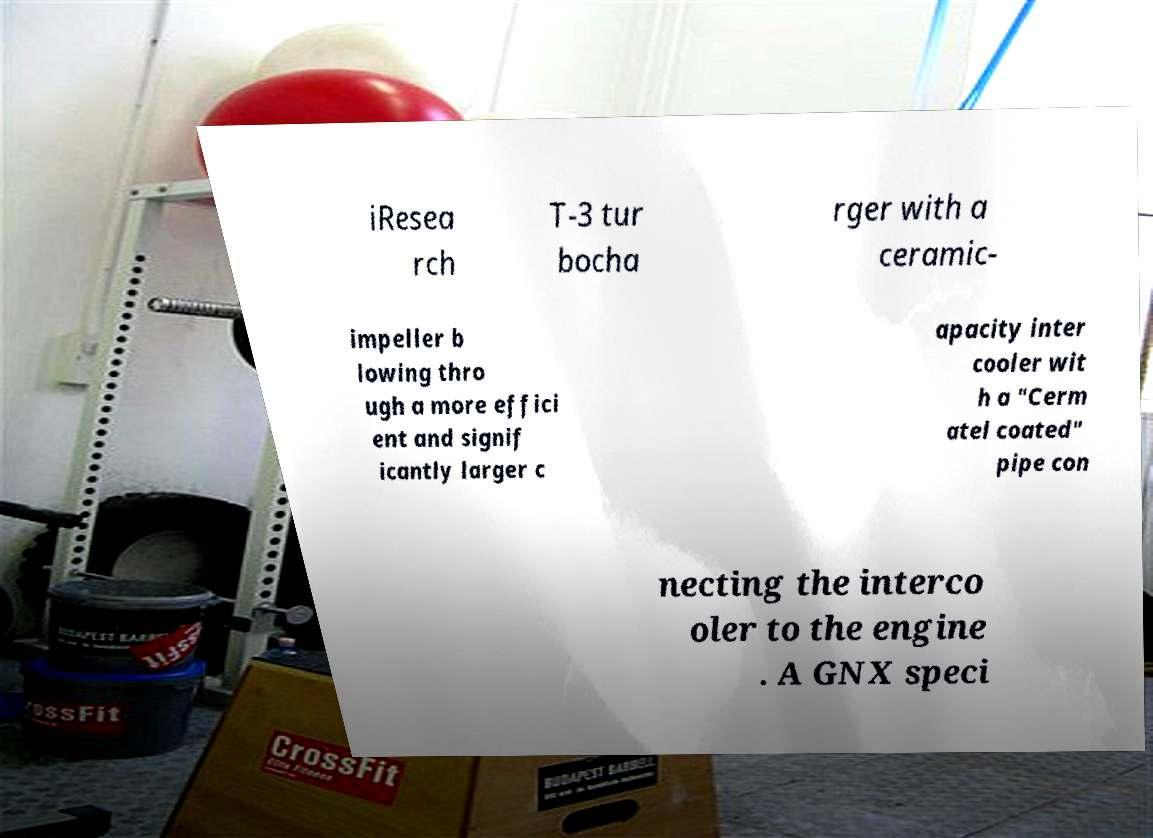I need the written content from this picture converted into text. Can you do that? iResea rch T-3 tur bocha rger with a ceramic- impeller b lowing thro ugh a more effici ent and signif icantly larger c apacity inter cooler wit h a "Cerm atel coated" pipe con necting the interco oler to the engine . A GNX speci 